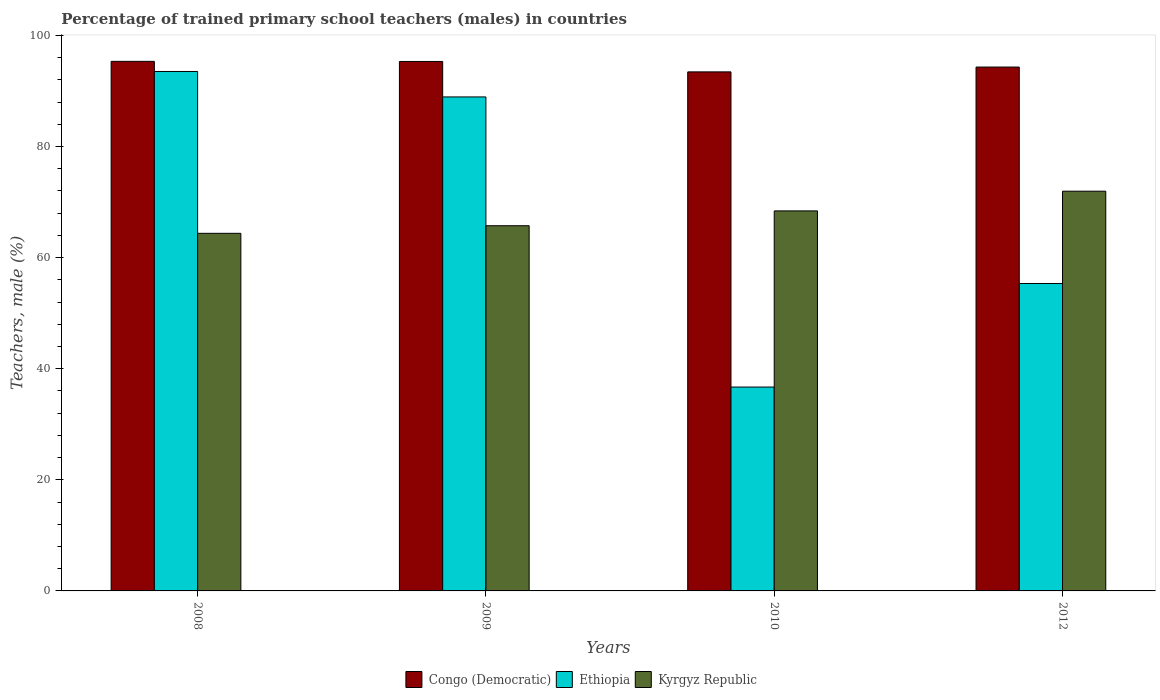How many groups of bars are there?
Provide a short and direct response. 4. Are the number of bars on each tick of the X-axis equal?
Your answer should be very brief. Yes. How many bars are there on the 2nd tick from the right?
Keep it short and to the point. 3. What is the label of the 4th group of bars from the left?
Make the answer very short. 2012. In how many cases, is the number of bars for a given year not equal to the number of legend labels?
Your answer should be very brief. 0. What is the percentage of trained primary school teachers (males) in Ethiopia in 2008?
Keep it short and to the point. 93.51. Across all years, what is the maximum percentage of trained primary school teachers (males) in Ethiopia?
Give a very brief answer. 93.51. Across all years, what is the minimum percentage of trained primary school teachers (males) in Ethiopia?
Provide a short and direct response. 36.7. In which year was the percentage of trained primary school teachers (males) in Kyrgyz Republic maximum?
Provide a succinct answer. 2012. In which year was the percentage of trained primary school teachers (males) in Kyrgyz Republic minimum?
Offer a very short reply. 2008. What is the total percentage of trained primary school teachers (males) in Kyrgyz Republic in the graph?
Ensure brevity in your answer.  270.49. What is the difference between the percentage of trained primary school teachers (males) in Ethiopia in 2008 and that in 2012?
Your answer should be very brief. 38.17. What is the difference between the percentage of trained primary school teachers (males) in Ethiopia in 2010 and the percentage of trained primary school teachers (males) in Kyrgyz Republic in 2012?
Offer a terse response. -35.26. What is the average percentage of trained primary school teachers (males) in Kyrgyz Republic per year?
Your response must be concise. 67.62. In the year 2008, what is the difference between the percentage of trained primary school teachers (males) in Congo (Democratic) and percentage of trained primary school teachers (males) in Ethiopia?
Offer a very short reply. 1.82. What is the ratio of the percentage of trained primary school teachers (males) in Congo (Democratic) in 2008 to that in 2010?
Give a very brief answer. 1.02. Is the percentage of trained primary school teachers (males) in Congo (Democratic) in 2008 less than that in 2012?
Make the answer very short. No. Is the difference between the percentage of trained primary school teachers (males) in Congo (Democratic) in 2010 and 2012 greater than the difference between the percentage of trained primary school teachers (males) in Ethiopia in 2010 and 2012?
Your response must be concise. Yes. What is the difference between the highest and the second highest percentage of trained primary school teachers (males) in Kyrgyz Republic?
Ensure brevity in your answer.  3.55. What is the difference between the highest and the lowest percentage of trained primary school teachers (males) in Ethiopia?
Make the answer very short. 56.81. In how many years, is the percentage of trained primary school teachers (males) in Ethiopia greater than the average percentage of trained primary school teachers (males) in Ethiopia taken over all years?
Give a very brief answer. 2. Is the sum of the percentage of trained primary school teachers (males) in Kyrgyz Republic in 2008 and 2012 greater than the maximum percentage of trained primary school teachers (males) in Congo (Democratic) across all years?
Your answer should be compact. Yes. What does the 3rd bar from the left in 2012 represents?
Ensure brevity in your answer.  Kyrgyz Republic. What does the 3rd bar from the right in 2012 represents?
Give a very brief answer. Congo (Democratic). How many bars are there?
Make the answer very short. 12. Are all the bars in the graph horizontal?
Your answer should be compact. No. Are the values on the major ticks of Y-axis written in scientific E-notation?
Provide a succinct answer. No. How many legend labels are there?
Your answer should be very brief. 3. How are the legend labels stacked?
Your answer should be very brief. Horizontal. What is the title of the graph?
Provide a short and direct response. Percentage of trained primary school teachers (males) in countries. Does "Romania" appear as one of the legend labels in the graph?
Offer a very short reply. No. What is the label or title of the X-axis?
Provide a succinct answer. Years. What is the label or title of the Y-axis?
Provide a succinct answer. Teachers, male (%). What is the Teachers, male (%) in Congo (Democratic) in 2008?
Offer a very short reply. 95.33. What is the Teachers, male (%) of Ethiopia in 2008?
Offer a terse response. 93.51. What is the Teachers, male (%) of Kyrgyz Republic in 2008?
Provide a short and direct response. 64.38. What is the Teachers, male (%) in Congo (Democratic) in 2009?
Keep it short and to the point. 95.32. What is the Teachers, male (%) in Ethiopia in 2009?
Your response must be concise. 88.93. What is the Teachers, male (%) in Kyrgyz Republic in 2009?
Provide a succinct answer. 65.74. What is the Teachers, male (%) in Congo (Democratic) in 2010?
Give a very brief answer. 93.44. What is the Teachers, male (%) in Ethiopia in 2010?
Ensure brevity in your answer.  36.7. What is the Teachers, male (%) in Kyrgyz Republic in 2010?
Your answer should be compact. 68.41. What is the Teachers, male (%) of Congo (Democratic) in 2012?
Your response must be concise. 94.31. What is the Teachers, male (%) in Ethiopia in 2012?
Keep it short and to the point. 55.34. What is the Teachers, male (%) of Kyrgyz Republic in 2012?
Provide a short and direct response. 71.96. Across all years, what is the maximum Teachers, male (%) in Congo (Democratic)?
Your response must be concise. 95.33. Across all years, what is the maximum Teachers, male (%) of Ethiopia?
Keep it short and to the point. 93.51. Across all years, what is the maximum Teachers, male (%) in Kyrgyz Republic?
Offer a terse response. 71.96. Across all years, what is the minimum Teachers, male (%) in Congo (Democratic)?
Make the answer very short. 93.44. Across all years, what is the minimum Teachers, male (%) of Ethiopia?
Your answer should be very brief. 36.7. Across all years, what is the minimum Teachers, male (%) in Kyrgyz Republic?
Offer a very short reply. 64.38. What is the total Teachers, male (%) in Congo (Democratic) in the graph?
Keep it short and to the point. 378.39. What is the total Teachers, male (%) of Ethiopia in the graph?
Make the answer very short. 274.48. What is the total Teachers, male (%) of Kyrgyz Republic in the graph?
Give a very brief answer. 270.49. What is the difference between the Teachers, male (%) of Congo (Democratic) in 2008 and that in 2009?
Make the answer very short. 0.02. What is the difference between the Teachers, male (%) in Ethiopia in 2008 and that in 2009?
Ensure brevity in your answer.  4.58. What is the difference between the Teachers, male (%) in Kyrgyz Republic in 2008 and that in 2009?
Ensure brevity in your answer.  -1.36. What is the difference between the Teachers, male (%) of Congo (Democratic) in 2008 and that in 2010?
Offer a very short reply. 1.89. What is the difference between the Teachers, male (%) of Ethiopia in 2008 and that in 2010?
Make the answer very short. 56.81. What is the difference between the Teachers, male (%) of Kyrgyz Republic in 2008 and that in 2010?
Give a very brief answer. -4.04. What is the difference between the Teachers, male (%) in Congo (Democratic) in 2008 and that in 2012?
Make the answer very short. 1.03. What is the difference between the Teachers, male (%) of Ethiopia in 2008 and that in 2012?
Ensure brevity in your answer.  38.17. What is the difference between the Teachers, male (%) of Kyrgyz Republic in 2008 and that in 2012?
Provide a short and direct response. -7.58. What is the difference between the Teachers, male (%) in Congo (Democratic) in 2009 and that in 2010?
Provide a succinct answer. 1.88. What is the difference between the Teachers, male (%) in Ethiopia in 2009 and that in 2010?
Offer a very short reply. 52.23. What is the difference between the Teachers, male (%) in Kyrgyz Republic in 2009 and that in 2010?
Give a very brief answer. -2.67. What is the difference between the Teachers, male (%) in Congo (Democratic) in 2009 and that in 2012?
Provide a succinct answer. 1.01. What is the difference between the Teachers, male (%) of Ethiopia in 2009 and that in 2012?
Keep it short and to the point. 33.59. What is the difference between the Teachers, male (%) in Kyrgyz Republic in 2009 and that in 2012?
Your answer should be compact. -6.22. What is the difference between the Teachers, male (%) in Congo (Democratic) in 2010 and that in 2012?
Give a very brief answer. -0.87. What is the difference between the Teachers, male (%) of Ethiopia in 2010 and that in 2012?
Give a very brief answer. -18.64. What is the difference between the Teachers, male (%) in Kyrgyz Republic in 2010 and that in 2012?
Offer a terse response. -3.55. What is the difference between the Teachers, male (%) of Congo (Democratic) in 2008 and the Teachers, male (%) of Ethiopia in 2009?
Ensure brevity in your answer.  6.4. What is the difference between the Teachers, male (%) in Congo (Democratic) in 2008 and the Teachers, male (%) in Kyrgyz Republic in 2009?
Your answer should be very brief. 29.59. What is the difference between the Teachers, male (%) in Ethiopia in 2008 and the Teachers, male (%) in Kyrgyz Republic in 2009?
Offer a very short reply. 27.77. What is the difference between the Teachers, male (%) in Congo (Democratic) in 2008 and the Teachers, male (%) in Ethiopia in 2010?
Keep it short and to the point. 58.63. What is the difference between the Teachers, male (%) in Congo (Democratic) in 2008 and the Teachers, male (%) in Kyrgyz Republic in 2010?
Your response must be concise. 26.92. What is the difference between the Teachers, male (%) in Ethiopia in 2008 and the Teachers, male (%) in Kyrgyz Republic in 2010?
Provide a short and direct response. 25.1. What is the difference between the Teachers, male (%) of Congo (Democratic) in 2008 and the Teachers, male (%) of Ethiopia in 2012?
Give a very brief answer. 39.99. What is the difference between the Teachers, male (%) in Congo (Democratic) in 2008 and the Teachers, male (%) in Kyrgyz Republic in 2012?
Your response must be concise. 23.38. What is the difference between the Teachers, male (%) of Ethiopia in 2008 and the Teachers, male (%) of Kyrgyz Republic in 2012?
Your answer should be compact. 21.55. What is the difference between the Teachers, male (%) of Congo (Democratic) in 2009 and the Teachers, male (%) of Ethiopia in 2010?
Make the answer very short. 58.61. What is the difference between the Teachers, male (%) in Congo (Democratic) in 2009 and the Teachers, male (%) in Kyrgyz Republic in 2010?
Give a very brief answer. 26.9. What is the difference between the Teachers, male (%) in Ethiopia in 2009 and the Teachers, male (%) in Kyrgyz Republic in 2010?
Your response must be concise. 20.52. What is the difference between the Teachers, male (%) of Congo (Democratic) in 2009 and the Teachers, male (%) of Ethiopia in 2012?
Ensure brevity in your answer.  39.97. What is the difference between the Teachers, male (%) in Congo (Democratic) in 2009 and the Teachers, male (%) in Kyrgyz Republic in 2012?
Give a very brief answer. 23.36. What is the difference between the Teachers, male (%) in Ethiopia in 2009 and the Teachers, male (%) in Kyrgyz Republic in 2012?
Make the answer very short. 16.97. What is the difference between the Teachers, male (%) in Congo (Democratic) in 2010 and the Teachers, male (%) in Ethiopia in 2012?
Give a very brief answer. 38.09. What is the difference between the Teachers, male (%) in Congo (Democratic) in 2010 and the Teachers, male (%) in Kyrgyz Republic in 2012?
Offer a terse response. 21.48. What is the difference between the Teachers, male (%) in Ethiopia in 2010 and the Teachers, male (%) in Kyrgyz Republic in 2012?
Offer a terse response. -35.26. What is the average Teachers, male (%) in Congo (Democratic) per year?
Keep it short and to the point. 94.6. What is the average Teachers, male (%) of Ethiopia per year?
Provide a succinct answer. 68.62. What is the average Teachers, male (%) in Kyrgyz Republic per year?
Provide a succinct answer. 67.62. In the year 2008, what is the difference between the Teachers, male (%) of Congo (Democratic) and Teachers, male (%) of Ethiopia?
Give a very brief answer. 1.82. In the year 2008, what is the difference between the Teachers, male (%) in Congo (Democratic) and Teachers, male (%) in Kyrgyz Republic?
Ensure brevity in your answer.  30.96. In the year 2008, what is the difference between the Teachers, male (%) of Ethiopia and Teachers, male (%) of Kyrgyz Republic?
Offer a terse response. 29.13. In the year 2009, what is the difference between the Teachers, male (%) of Congo (Democratic) and Teachers, male (%) of Ethiopia?
Offer a terse response. 6.39. In the year 2009, what is the difference between the Teachers, male (%) of Congo (Democratic) and Teachers, male (%) of Kyrgyz Republic?
Offer a very short reply. 29.57. In the year 2009, what is the difference between the Teachers, male (%) in Ethiopia and Teachers, male (%) in Kyrgyz Republic?
Provide a succinct answer. 23.19. In the year 2010, what is the difference between the Teachers, male (%) in Congo (Democratic) and Teachers, male (%) in Ethiopia?
Your answer should be compact. 56.74. In the year 2010, what is the difference between the Teachers, male (%) in Congo (Democratic) and Teachers, male (%) in Kyrgyz Republic?
Your answer should be compact. 25.03. In the year 2010, what is the difference between the Teachers, male (%) of Ethiopia and Teachers, male (%) of Kyrgyz Republic?
Your answer should be compact. -31.71. In the year 2012, what is the difference between the Teachers, male (%) in Congo (Democratic) and Teachers, male (%) in Ethiopia?
Offer a terse response. 38.96. In the year 2012, what is the difference between the Teachers, male (%) in Congo (Democratic) and Teachers, male (%) in Kyrgyz Republic?
Your answer should be compact. 22.35. In the year 2012, what is the difference between the Teachers, male (%) in Ethiopia and Teachers, male (%) in Kyrgyz Republic?
Your response must be concise. -16.61. What is the ratio of the Teachers, male (%) of Ethiopia in 2008 to that in 2009?
Provide a succinct answer. 1.05. What is the ratio of the Teachers, male (%) of Kyrgyz Republic in 2008 to that in 2009?
Keep it short and to the point. 0.98. What is the ratio of the Teachers, male (%) in Congo (Democratic) in 2008 to that in 2010?
Give a very brief answer. 1.02. What is the ratio of the Teachers, male (%) in Ethiopia in 2008 to that in 2010?
Provide a short and direct response. 2.55. What is the ratio of the Teachers, male (%) of Kyrgyz Republic in 2008 to that in 2010?
Make the answer very short. 0.94. What is the ratio of the Teachers, male (%) in Congo (Democratic) in 2008 to that in 2012?
Keep it short and to the point. 1.01. What is the ratio of the Teachers, male (%) in Ethiopia in 2008 to that in 2012?
Your answer should be very brief. 1.69. What is the ratio of the Teachers, male (%) of Kyrgyz Republic in 2008 to that in 2012?
Provide a short and direct response. 0.89. What is the ratio of the Teachers, male (%) in Congo (Democratic) in 2009 to that in 2010?
Offer a very short reply. 1.02. What is the ratio of the Teachers, male (%) in Ethiopia in 2009 to that in 2010?
Make the answer very short. 2.42. What is the ratio of the Teachers, male (%) of Kyrgyz Republic in 2009 to that in 2010?
Ensure brevity in your answer.  0.96. What is the ratio of the Teachers, male (%) in Congo (Democratic) in 2009 to that in 2012?
Your answer should be compact. 1.01. What is the ratio of the Teachers, male (%) of Ethiopia in 2009 to that in 2012?
Offer a terse response. 1.61. What is the ratio of the Teachers, male (%) of Kyrgyz Republic in 2009 to that in 2012?
Keep it short and to the point. 0.91. What is the ratio of the Teachers, male (%) of Congo (Democratic) in 2010 to that in 2012?
Ensure brevity in your answer.  0.99. What is the ratio of the Teachers, male (%) of Ethiopia in 2010 to that in 2012?
Your response must be concise. 0.66. What is the ratio of the Teachers, male (%) of Kyrgyz Republic in 2010 to that in 2012?
Make the answer very short. 0.95. What is the difference between the highest and the second highest Teachers, male (%) in Congo (Democratic)?
Your answer should be compact. 0.02. What is the difference between the highest and the second highest Teachers, male (%) of Ethiopia?
Provide a succinct answer. 4.58. What is the difference between the highest and the second highest Teachers, male (%) in Kyrgyz Republic?
Keep it short and to the point. 3.55. What is the difference between the highest and the lowest Teachers, male (%) of Congo (Democratic)?
Provide a short and direct response. 1.89. What is the difference between the highest and the lowest Teachers, male (%) in Ethiopia?
Ensure brevity in your answer.  56.81. What is the difference between the highest and the lowest Teachers, male (%) of Kyrgyz Republic?
Keep it short and to the point. 7.58. 